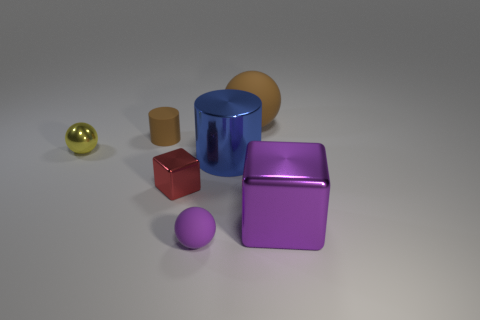Add 1 big brown things. How many objects exist? 8 Subtract all cylinders. How many objects are left? 5 Add 7 purple rubber spheres. How many purple rubber spheres are left? 8 Add 1 brown matte objects. How many brown matte objects exist? 3 Subtract 0 gray cylinders. How many objects are left? 7 Subtract all small brown things. Subtract all shiny balls. How many objects are left? 5 